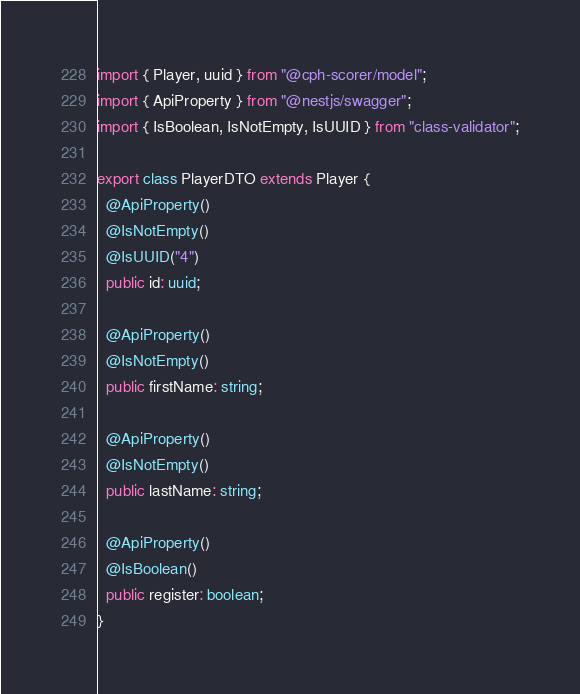<code> <loc_0><loc_0><loc_500><loc_500><_TypeScript_>import { Player, uuid } from "@cph-scorer/model";
import { ApiProperty } from "@nestjs/swagger";
import { IsBoolean, IsNotEmpty, IsUUID } from "class-validator";

export class PlayerDTO extends Player {
  @ApiProperty()
  @IsNotEmpty()
  @IsUUID("4")
  public id: uuid;

  @ApiProperty()
  @IsNotEmpty()
  public firstName: string;

  @ApiProperty()
  @IsNotEmpty()
  public lastName: string;

  @ApiProperty()
  @IsBoolean()
  public register: boolean;
}
</code> 